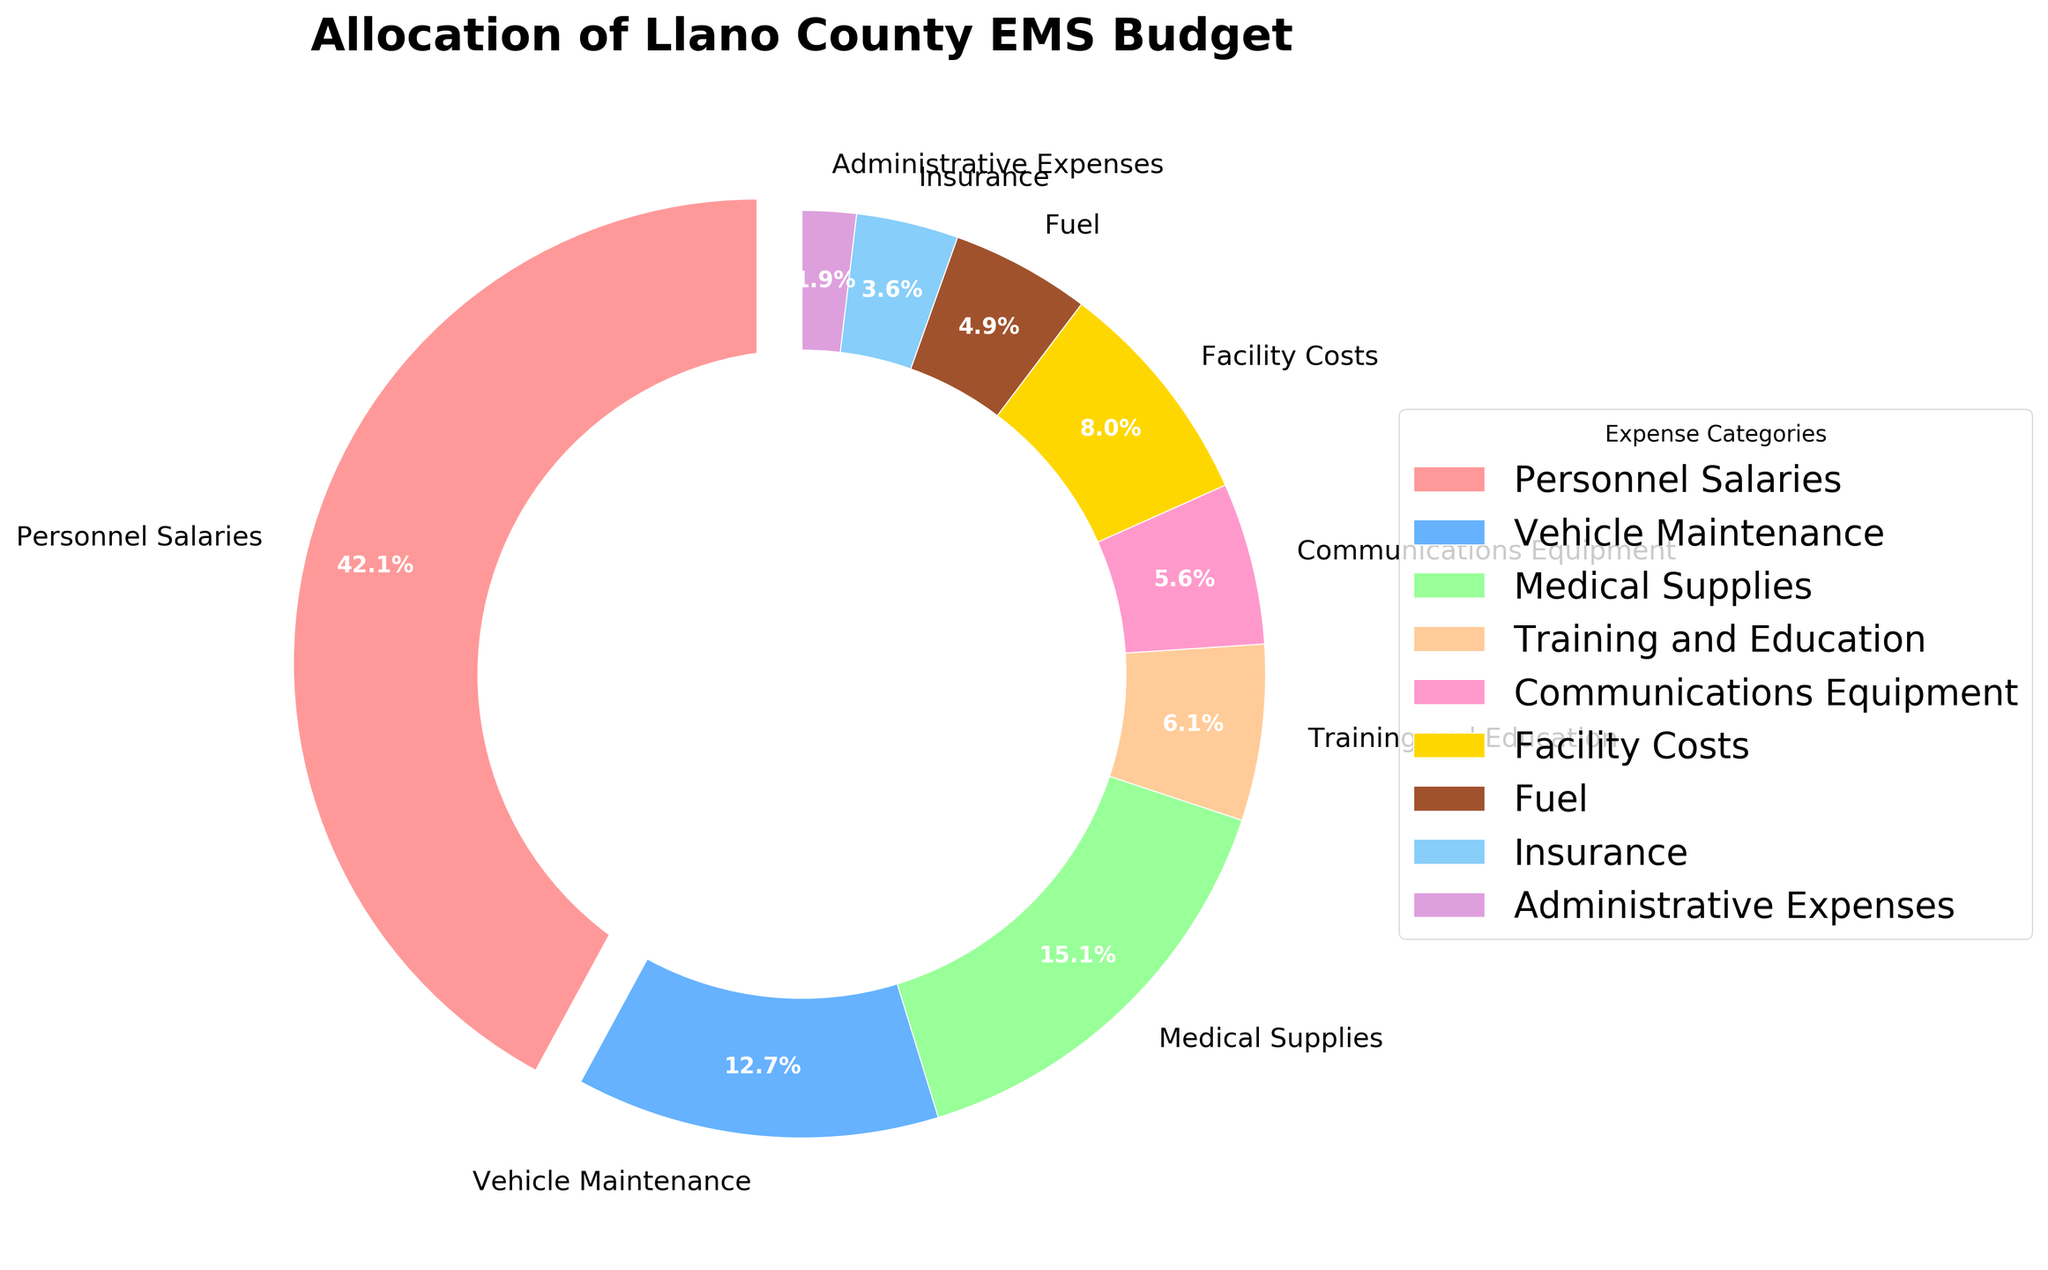How much of the budget is allocated to Medical Supplies and Vehicle Maintenance combined? First, locate the percentages for Medical Supplies (15.3%) and Vehicle Maintenance (12.8%) in the pie chart. Then, add these percentages together: 15.3% + 12.8% = 28.1%.
Answer: 28.1% What category receives the smallest percentage of the budget? Identify the slice with the smallest percentage on the chart. The smallest slice represents Administrative Expenses, which receives 1.9% of the budget.
Answer: Administrative Expenses How much more is allocated to Personnel Salaries compared to Fuel? Find the percentages for Personnel Salaries (42.5%) and Fuel (4.9%) in the pie chart. Then, calculate the difference: 42.5% - 4.9% = 37.6%.
Answer: 37.6% Which expense categories receive a larger portion of the budget than Training and Education? First, locate the percentage for Training and Education (6.2%). Then identify all categories with a higher percentage: Personnel Salaries (42.5%), Medical Supplies (15.3%), Vehicle Maintenance (12.8%), and Facility Costs (8.1%).
Answer: Personnel Salaries, Medical Supplies, Vehicle Maintenance, Facility Costs If Personnel Salaries were reduced by 10%, what would the new percentage be? Calculate 10% of the Personnel Salaries percentage: 10% * 42.5% = 4.25%. Then, subtract this from the original percentage: 42.5% - 4.25% = 38.25%.
Answer: 38.25% Which category has the slice that's colored blue? Identify the color blue in the chart legend, which corresponds to Vehicle Maintenance.
Answer: Vehicle Maintenance How many categories receive less than 10% of the budget? Identify all categories with percentages below 10%: Training and Education (6.2%), Communications Equipment (5.7%), Fuel (4.9%), Insurance (3.6%), Administrative Expenses (1.9%). Count these categories: there are 5.
Answer: 5 What is the average percentage of the top three budget categories? Identify the top three categories: Personnel Salaries (42.5%), Medical Supplies (15.3%), Vehicle Maintenance (12.8%). Calculate the average: (42.5% + 15.3% + 12.8%) / 3 = 23.53%.
Answer: 23.53% Which is higher, the combined percentage of Facility Costs and Communications Equipment or Medical Supplies alone? Add the percentages for Facility Costs (8.1%) and Communications Equipment (5.7%): 8.1% + 5.7% = 13.8%. Compare this to the percentage for Medical Supplies (15.3%): 15.3% > 13.8%.
Answer: Medical Supplies alone 